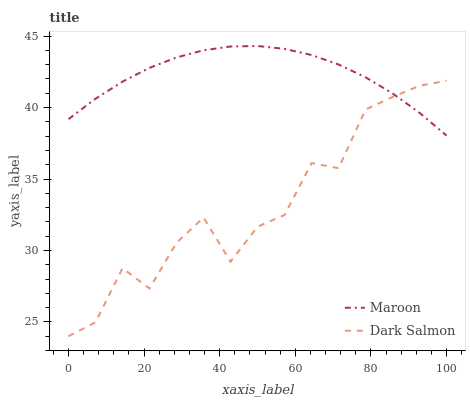Does Dark Salmon have the minimum area under the curve?
Answer yes or no. Yes. Does Maroon have the maximum area under the curve?
Answer yes or no. Yes. Does Maroon have the minimum area under the curve?
Answer yes or no. No. Is Maroon the smoothest?
Answer yes or no. Yes. Is Dark Salmon the roughest?
Answer yes or no. Yes. Is Maroon the roughest?
Answer yes or no. No. Does Dark Salmon have the lowest value?
Answer yes or no. Yes. Does Maroon have the lowest value?
Answer yes or no. No. Does Maroon have the highest value?
Answer yes or no. Yes. Does Maroon intersect Dark Salmon?
Answer yes or no. Yes. Is Maroon less than Dark Salmon?
Answer yes or no. No. Is Maroon greater than Dark Salmon?
Answer yes or no. No. 